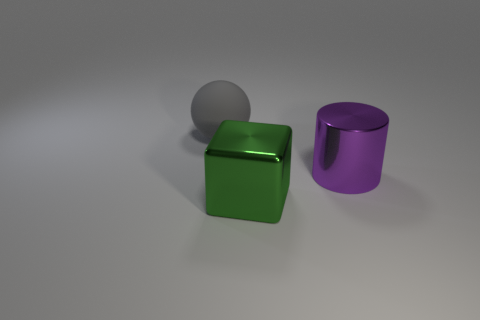How many objects are large shiny objects behind the big metal cube or big metal objects on the left side of the big purple cylinder?
Your answer should be very brief. 2. Is the number of metallic objects that are right of the green thing greater than the number of large shiny cylinders that are behind the purple shiny cylinder?
Offer a terse response. Yes. The object left of the large metallic thing left of the big metallic object behind the large metal cube is made of what material?
Your answer should be very brief. Rubber. There is a thing left of the green block; is it the same shape as the large purple shiny thing on the right side of the large green metal object?
Make the answer very short. No. Are there any other purple metal things that have the same size as the purple thing?
Offer a terse response. No. How many yellow objects are large spheres or large metal things?
Give a very brief answer. 0. Are there any other things that have the same shape as the big purple object?
Offer a terse response. No. What number of spheres are rubber objects or metallic things?
Your response must be concise. 1. There is a big shiny thing that is behind the green cube; what is its color?
Your answer should be very brief. Purple. What shape is the other rubber thing that is the same size as the purple object?
Offer a terse response. Sphere. 